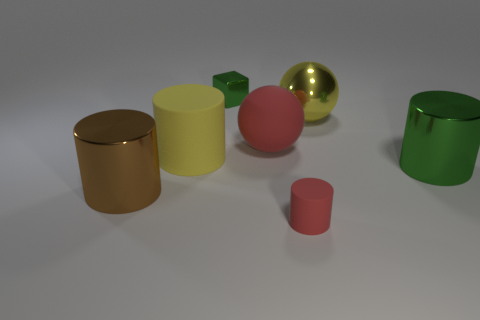There is a matte cylinder behind the big cylinder that is right of the rubber thing to the left of the green block; what size is it? The matte cylinder located behind the large cylinder, which is to the right of the rubber item and left of the green block, is medium-sized compared to the other objects in the image. 